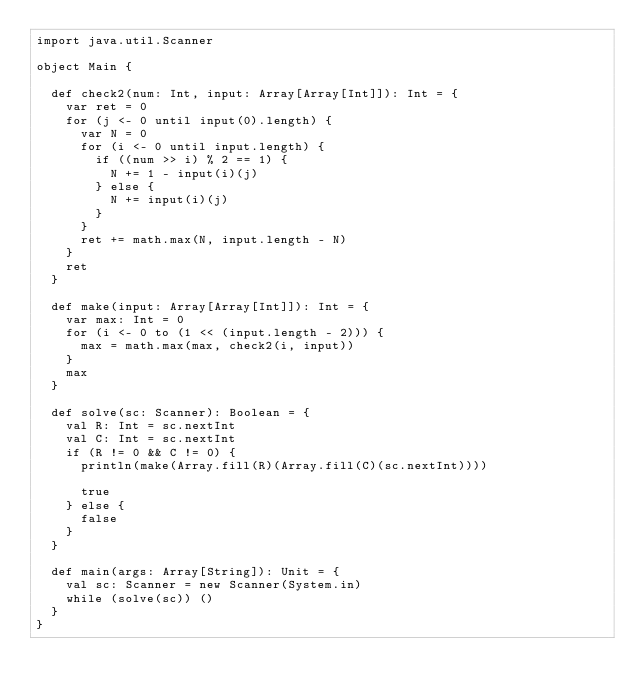Convert code to text. <code><loc_0><loc_0><loc_500><loc_500><_Scala_>import java.util.Scanner

object Main {

  def check2(num: Int, input: Array[Array[Int]]): Int = {
    var ret = 0
    for (j <- 0 until input(0).length) {
      var N = 0
      for (i <- 0 until input.length) {
        if ((num >> i) % 2 == 1) {
          N += 1 - input(i)(j)
        } else {
          N += input(i)(j)
        }
      }
      ret += math.max(N, input.length - N)
    }
    ret
  }

  def make(input: Array[Array[Int]]): Int = {
    var max: Int = 0
    for (i <- 0 to (1 << (input.length - 2))) {
      max = math.max(max, check2(i, input))
    }
    max
  }

  def solve(sc: Scanner): Boolean = {
    val R: Int = sc.nextInt
    val C: Int = sc.nextInt
    if (R != 0 && C != 0) {
      println(make(Array.fill(R)(Array.fill(C)(sc.nextInt))))

      true
    } else {
      false
    }
  }

  def main(args: Array[String]): Unit = {
    val sc: Scanner = new Scanner(System.in)
    while (solve(sc)) ()
  }
}</code> 